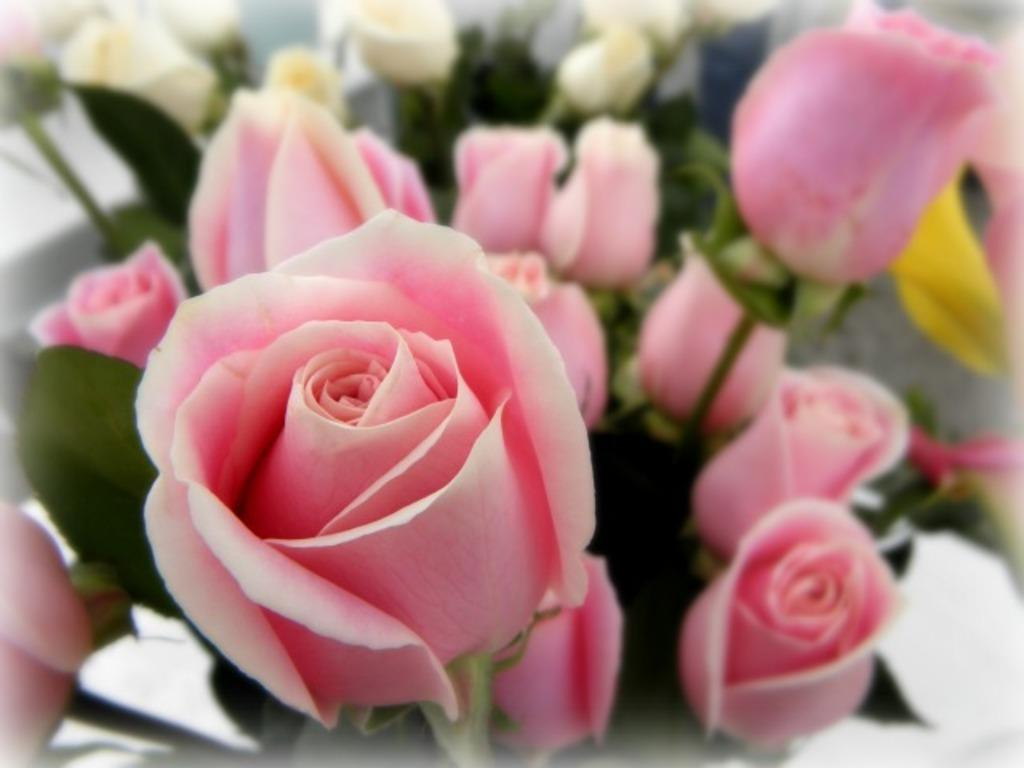What type of flowers are present in the image? There are pink roses and white roses with leaves in the image. Can you describe the color of the roses? The pink roses are pink, and the white roses are white. Are there any leaves visible with the roses? Yes, there are leaves visible with both the pink and white roses. What type of feast is being prepared with the roses in the image? There is no feast being prepared in the image; it simply features pink and white roses with leaves. 